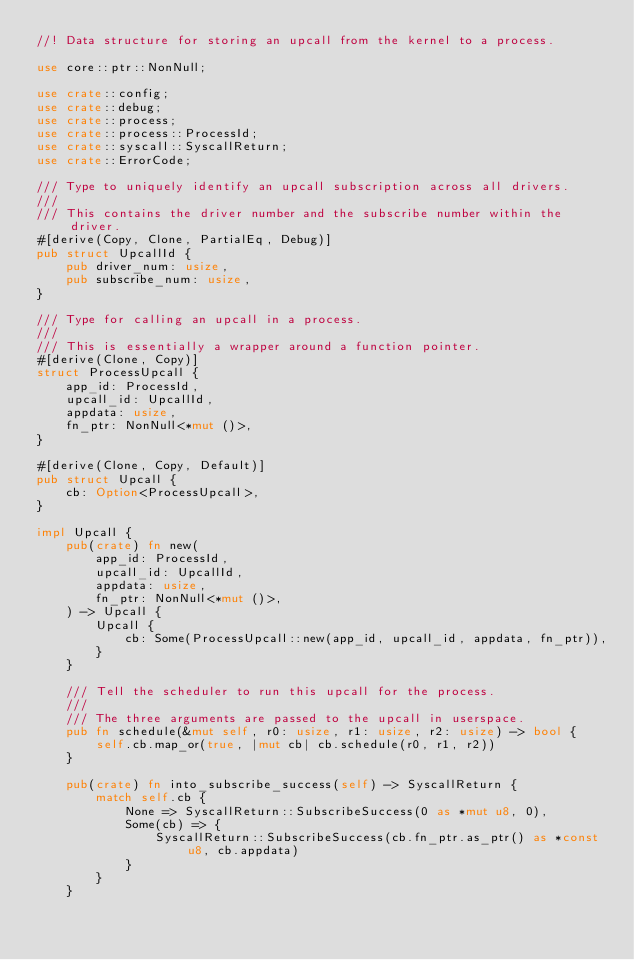Convert code to text. <code><loc_0><loc_0><loc_500><loc_500><_Rust_>//! Data structure for storing an upcall from the kernel to a process.

use core::ptr::NonNull;

use crate::config;
use crate::debug;
use crate::process;
use crate::process::ProcessId;
use crate::syscall::SyscallReturn;
use crate::ErrorCode;

/// Type to uniquely identify an upcall subscription across all drivers.
///
/// This contains the driver number and the subscribe number within the driver.
#[derive(Copy, Clone, PartialEq, Debug)]
pub struct UpcallId {
    pub driver_num: usize,
    pub subscribe_num: usize,
}

/// Type for calling an upcall in a process.
///
/// This is essentially a wrapper around a function pointer.
#[derive(Clone, Copy)]
struct ProcessUpcall {
    app_id: ProcessId,
    upcall_id: UpcallId,
    appdata: usize,
    fn_ptr: NonNull<*mut ()>,
}

#[derive(Clone, Copy, Default)]
pub struct Upcall {
    cb: Option<ProcessUpcall>,
}

impl Upcall {
    pub(crate) fn new(
        app_id: ProcessId,
        upcall_id: UpcallId,
        appdata: usize,
        fn_ptr: NonNull<*mut ()>,
    ) -> Upcall {
        Upcall {
            cb: Some(ProcessUpcall::new(app_id, upcall_id, appdata, fn_ptr)),
        }
    }

    /// Tell the scheduler to run this upcall for the process.
    ///
    /// The three arguments are passed to the upcall in userspace.
    pub fn schedule(&mut self, r0: usize, r1: usize, r2: usize) -> bool {
        self.cb.map_or(true, |mut cb| cb.schedule(r0, r1, r2))
    }

    pub(crate) fn into_subscribe_success(self) -> SyscallReturn {
        match self.cb {
            None => SyscallReturn::SubscribeSuccess(0 as *mut u8, 0),
            Some(cb) => {
                SyscallReturn::SubscribeSuccess(cb.fn_ptr.as_ptr() as *const u8, cb.appdata)
            }
        }
    }
</code> 